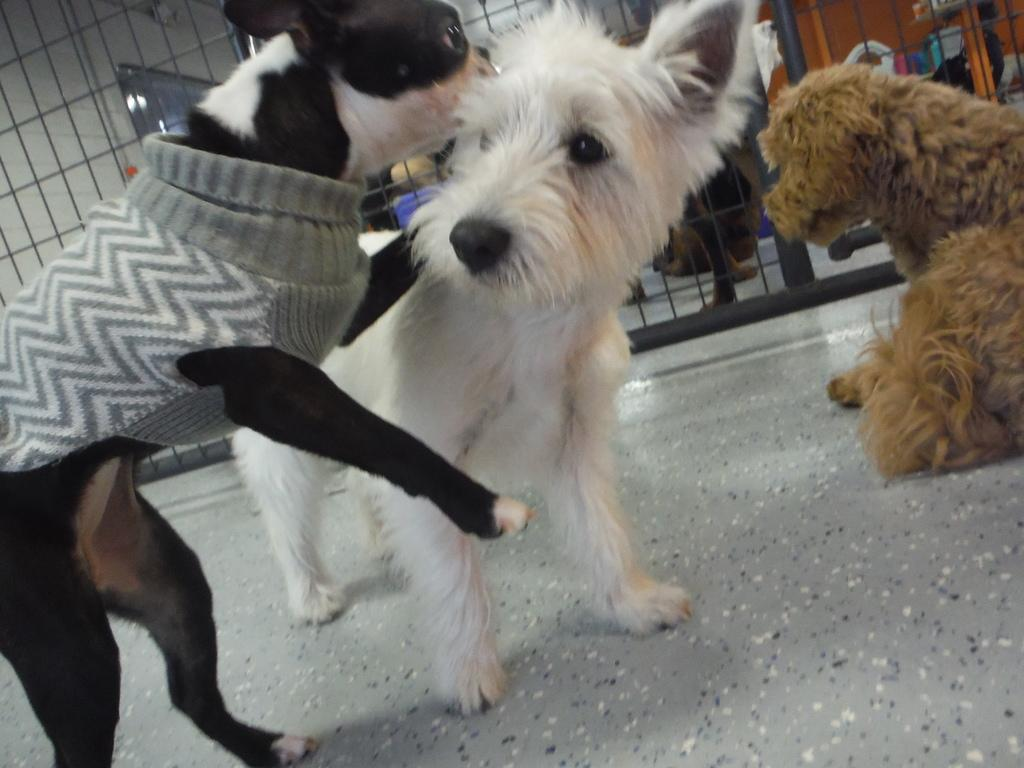How many dogs are present in the image? There are three dogs on the floor in the image. What can be seen in the background of the image? There is a net and other objects visible in the background of the image. How many legs does the account have in the image? There is no account present in the image, so it is not possible to determine how many legs it might have. 